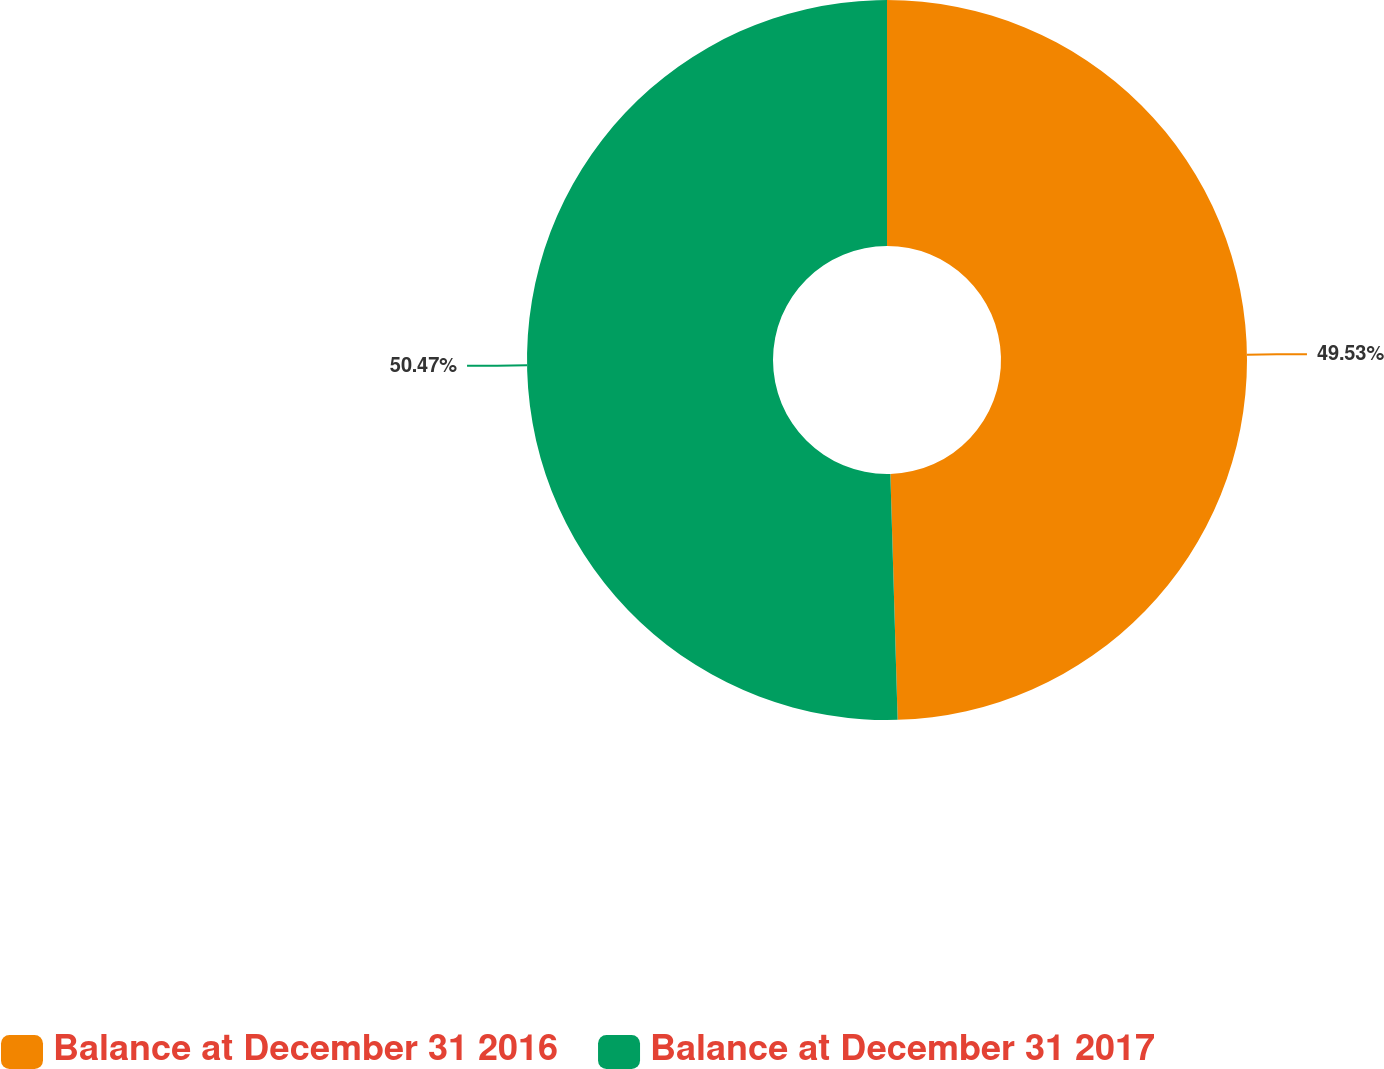<chart> <loc_0><loc_0><loc_500><loc_500><pie_chart><fcel>Balance at December 31 2016<fcel>Balance at December 31 2017<nl><fcel>49.53%<fcel>50.47%<nl></chart> 